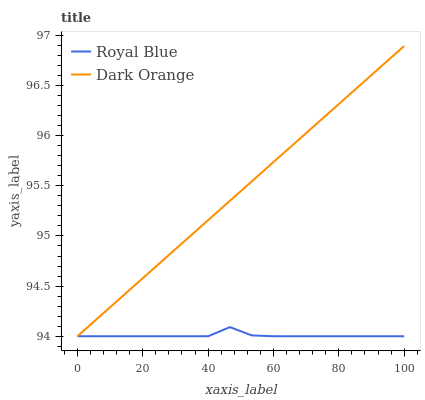Does Dark Orange have the minimum area under the curve?
Answer yes or no. No. Is Dark Orange the roughest?
Answer yes or no. No. 